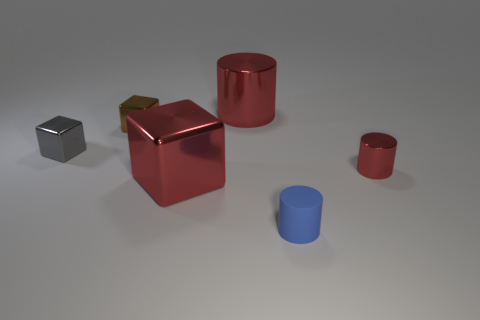Add 2 brown things. How many objects exist? 8 Add 6 big purple balls. How many big purple balls exist? 6 Subtract 0 yellow cylinders. How many objects are left? 6 Subtract all small brown metal objects. Subtract all tiny yellow matte cylinders. How many objects are left? 5 Add 4 small cubes. How many small cubes are left? 6 